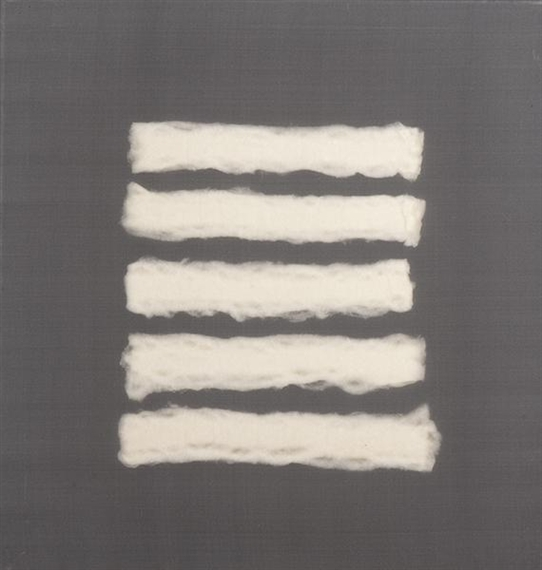Imagine the story behind this artwork. How do you think the artist felt while creating it? One can imagine the artist approaching this piece with a profound sense of calm and contemplation. The gentle, repetitive placement of the white strips suggests a meditative process, as though the artist was immersed in a rhythm of creation, perhaps seeking solace or expressing an internal state of tranquility. The simplicity and purity of the design could reflect the artist's desire for clarity and peace, while the subtle variances and textures speak to the complexities and nuances of emotion. The act of arranging these soft, organic forms against a monochrome background might have been therapeutic, offering a way to visually articulate feelings that are both delicate and profound. That's very thoughtful. Do you think this piece could symbolize something in particular? The artwork could symbolize a range of themes, from the passage of time to the simplicity in life's complexities. The repeated, horizontal white strips might represent the different layers or stages of life, each unique yet part of a whole continuum. Alternatively, the juxtaposition of the soft, irregular lines against a solid, gray background could signify the interplay between vulnerability and resilience. The piece might also be interpreted as a visual representation of balance and harmony, with the minimalistic design inviting viewers to reflect on the importance of simplicity and quiet moments in a chaotic world. Ultimately, the open-ended nature of abstract art allows each viewer to project their own meanings and emotions onto the work. 